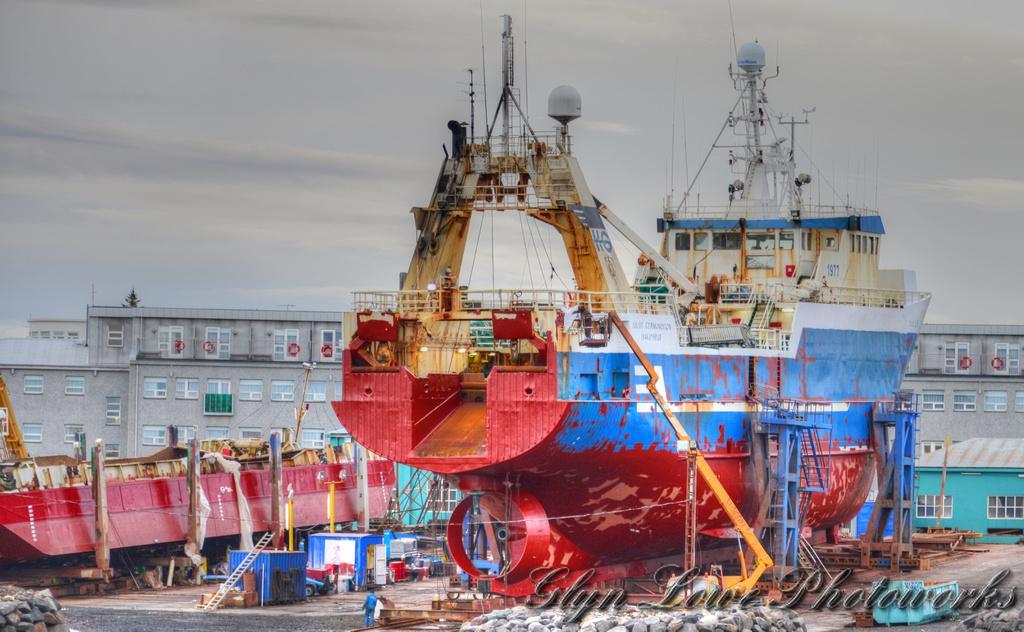Could you give a brief overview of what you see in this image? In the foreground of the picture we can see buildings, ship, rocks, people, machinery, road and various objects. At the top there is sky. 